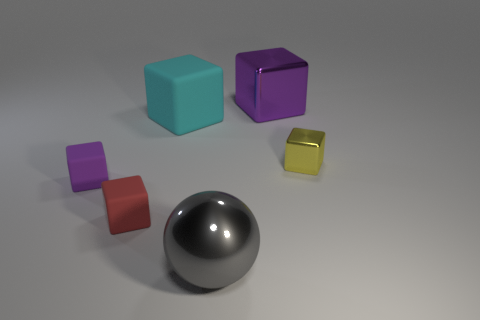Subtract all big cyan cubes. How many cubes are left? 4 Add 3 gray spheres. How many objects exist? 9 Subtract all cyan cubes. How many cubes are left? 4 Subtract 1 cubes. How many cubes are left? 4 Add 3 purple metal objects. How many purple metal objects exist? 4 Subtract 0 brown cylinders. How many objects are left? 6 Subtract all cubes. How many objects are left? 1 Subtract all purple cubes. Subtract all purple cylinders. How many cubes are left? 3 Subtract all cyan blocks. How many brown balls are left? 0 Subtract all large shiny balls. Subtract all tiny purple objects. How many objects are left? 4 